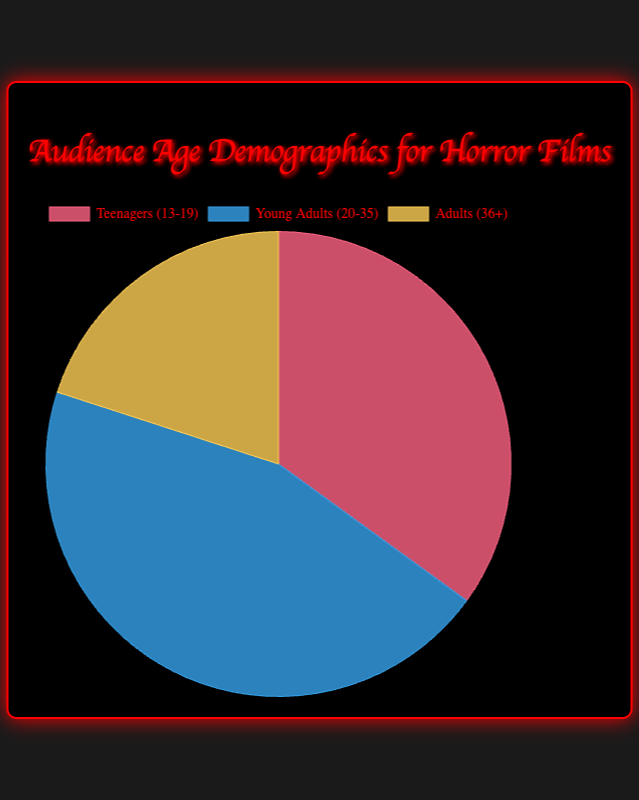What is the most represented age demographic in the audience? The largest slice of the pie chart represents Young Adults (20-35) with 45%.
Answer: Young Adults (20-35) Which age demographic is the least represented? The smallest slice in the pie chart represents Adults (36+), which constitutes 20% of the audience.
Answer: Adults (36+) What is the total percentage of the audience formed by Teenagers (13-19) and Adults (36+)? Add the percentages of Teenagers (13-19) and Adults (36+). So, 35% + 20% = 55%.
Answer: 55% How many percentage points more do Young Adults (20-35) represent compared to Adults (36+)? Subtract the percentage of Adults (36+) from the percentage of Young Adults (20-35). So, 45% - 20% = 25%.
Answer: 25% Which category is represented by the blue section of the pie chart? The blue section of the pie chart corresponds to Young Adults (20-35) as indicated by the color legend.
Answer: Young Adults (20-35) What percentage of the audience is either Teenagers (13-19) or Young Adults (20-35)? Combine the percentages of Teenagers (13-19) and Young Adults (20-35). So, 35% + 45% = 80%.
Answer: 80% If the percentages were to be equally distributed among the three age groups, what would be the difference in percentage for Teenagers (13-19)? Each group would equally represent 33.33%. The difference would be calculated by 35% - 33.33%, which is approximately 1.67%.
Answer: Approximately 1.67% What color represents the Teenagers (13-19) demographic? According to the pie chart legend, the red color represents the Teenagers (13-19) demographic.
Answer: Red Which two age groups combined represent less than half of the total audience? Combine the percentages of Teenagers (13-19) and Adults (36+). So, 35% + 20% = 55%, and Teenagers (13-19) + Young Adults (20-35) is 35% + 45% = 80%. Only Adults (36+) are together alone less than the half total.
Answer: Adults (36+) What is the average percentage of the three age demographics? Sum the percentages of all three age groups and divide by 3. So, (35% + 45% + 20%) / 3 = 33.33%.
Answer: 33.33% 